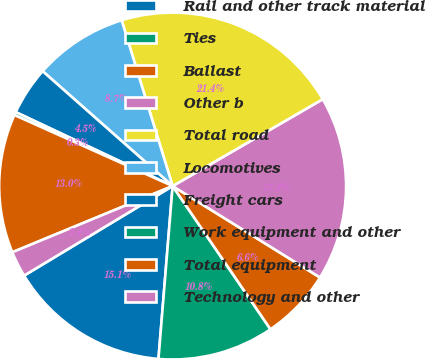<chart> <loc_0><loc_0><loc_500><loc_500><pie_chart><fcel>Rail and other track material<fcel>Ties<fcel>Ballast<fcel>Other b<fcel>Total road<fcel>Locomotives<fcel>Freight cars<fcel>Work equipment and other<fcel>Total equipment<fcel>Technology and other<nl><fcel>15.06%<fcel>10.84%<fcel>6.62%<fcel>17.18%<fcel>21.4%<fcel>8.73%<fcel>4.51%<fcel>0.29%<fcel>12.95%<fcel>2.4%<nl></chart> 